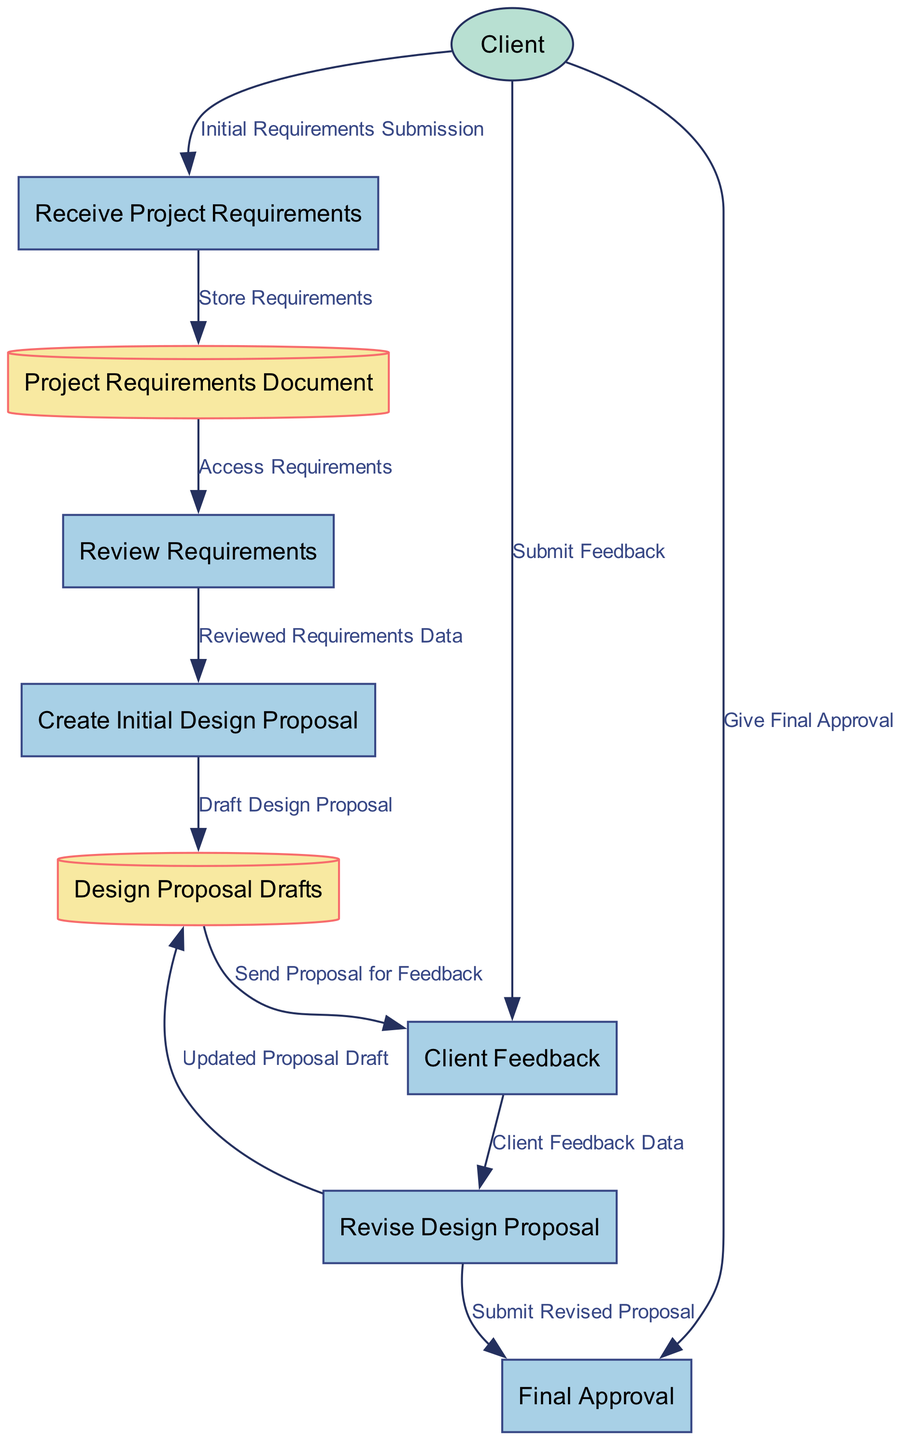What is the first process in the diagram? The diagram lists the processes in order, starting with the "Receive Project Requirements" as the first process.
Answer: Receive Project Requirements How many processes are shown in the diagram? By counting the entries under the "Processes" section, there are six distinct processes identified.
Answer: Six Which data store is used to keep the project requirements? The "Project Requirements Document" data store is specifically indicated for storing detailed project requirements from the client.
Answer: Project Requirements Document What type of data flows from the "Client" to the "Receive Project Requirements"? The initial data flow from the "Client" to "Receive Project Requirements" is labeled as "Initial Requirements Submission."
Answer: Initial Requirements Submission After "Client Feedback," what is the next process? After the "Client Feedback" process, the diagram shows that the next step is to "Revise Design Proposal." This indicates a sequential flow from the client feedback to revising the proposal.
Answer: Revise Design Proposal How many data stores are present in the diagram? The diagram identifies two data stores: "Project Requirements Document" and "Design Proposal Drafts," meaning there are two distinct data stores.
Answer: Two What is sent to the client for feedback? The output of the "Create Initial Design Proposal" process is sent to the client as indicated by the data flow labeled "Send Proposal for Feedback."
Answer: Draft Design Proposal What feedback does the client submit after reviewing the initial design proposal? The feedback submitted by the client is referred to as "Client Feedback Data," which shows that it relates directly to their observations on the proposal.
Answer: Client Feedback Data Which process requires access to "Project Requirements Document"? The "Review Requirements" process needs to access the "Project Requirements Document," as indicated by the data flow connected to it.
Answer: Review Requirements What approval does the client give at the final stage? At the final stage, the client provides "Final Approval" for the design proposal, marking the completion of the approval process.
Answer: Final Approval 